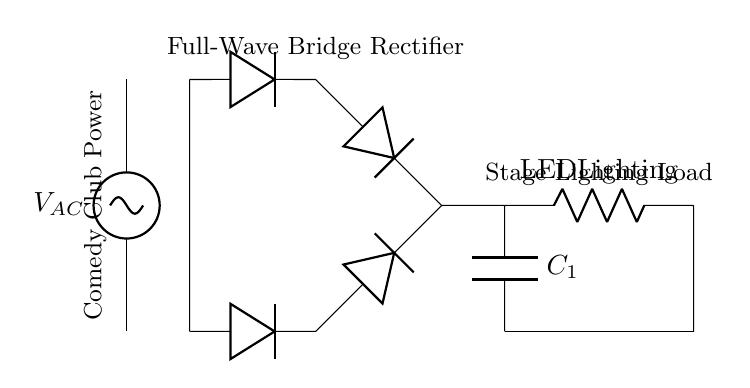What is the type of rectifier used in this circuit? The circuit diagram illustrates a full-wave bridge rectifier, identified by the configuration of four diodes in a bridge setup that converts alternating current to direct current.
Answer: Full-wave bridge rectifier What component smooths the output voltage? The smoothing capacitor, labeled C1 in the diagram, is included to reduce voltage ripples from the rectifier output, providing a more stable direct current to the load.
Answer: C1 What type of load is connected to this rectifier circuit? The circuit is configured to power LED stage lighting, indicated by the label "LED Lighting" associated with the load resistor shown in the diagram.
Answer: LED Lighting How many diodes are present in this circuit? The bridge rectifier specifically utilizes four diodes to achieve full-wave rectification, allowing current to flow through the load during both halves of the AC cycle.
Answer: Four diodes What is the purpose of the AC voltage source in this circuit? The AC voltage source, labeled VAC, functions as the input power supply necessary to perform the rectification process, converting AC to DC for the LED stage lighting.
Answer: Input power supply What is the role of the diodes in this circuit? The diodes in the bridge configuration are responsible for allowing current to pass in one direction only, effectively converting the AC input voltage into a pulsating DC output that can be smoothed by the capacitor.
Answer: Allowing current in one direction 